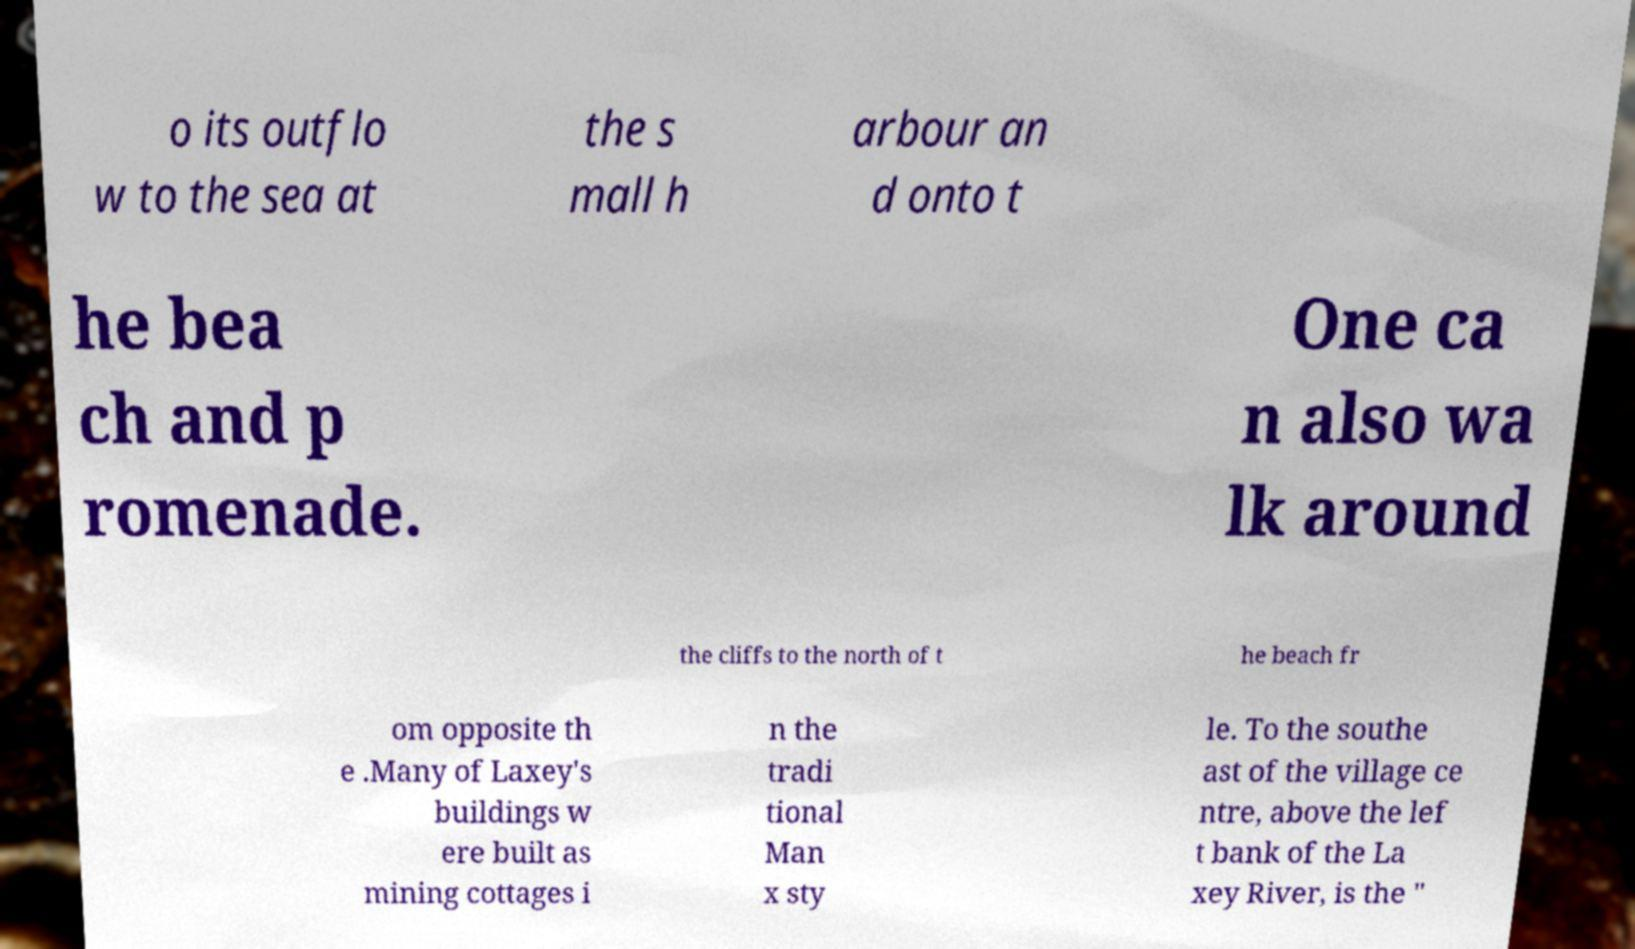Please read and relay the text visible in this image. What does it say? o its outflo w to the sea at the s mall h arbour an d onto t he bea ch and p romenade. One ca n also wa lk around the cliffs to the north of t he beach fr om opposite th e .Many of Laxey's buildings w ere built as mining cottages i n the tradi tional Man x sty le. To the southe ast of the village ce ntre, above the lef t bank of the La xey River, is the " 